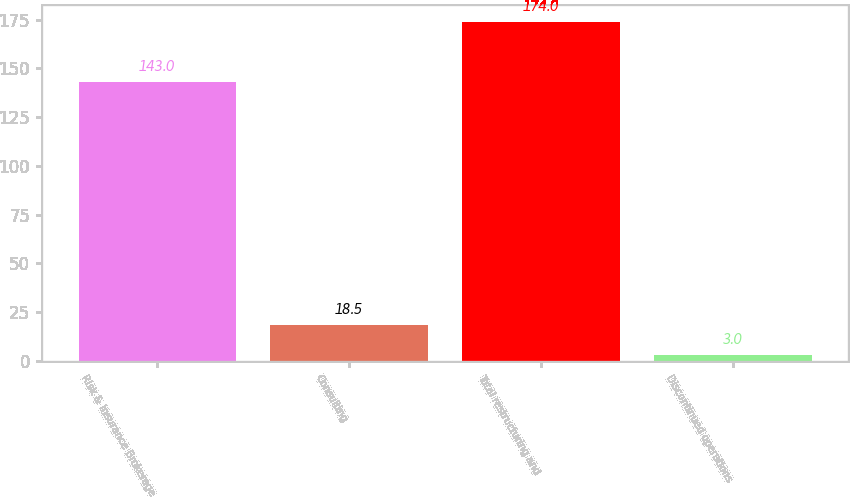<chart> <loc_0><loc_0><loc_500><loc_500><bar_chart><fcel>Risk & Insurance Brokerage<fcel>Consulting<fcel>Total restructuring and<fcel>Discontinued operations<nl><fcel>143<fcel>18.5<fcel>174<fcel>3<nl></chart> 